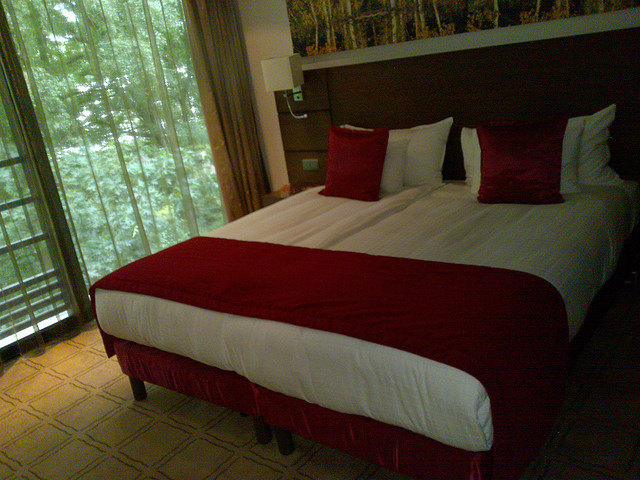<image>How old is this blanket? It is unknown how old this blanket is. It could be new or it could be a month old. What type of pattern can be found on the folded blanket? It is ambiguous what pattern can be found on the folded blanket. It could be solid or none. How old is this blanket? It is unknown how old this blanket is. However, it looks new. What type of pattern can be found on the folded blanket? There is ambiguity in determining the type of pattern on the folded blanket. It can be seen as solid, quilted or plain. 